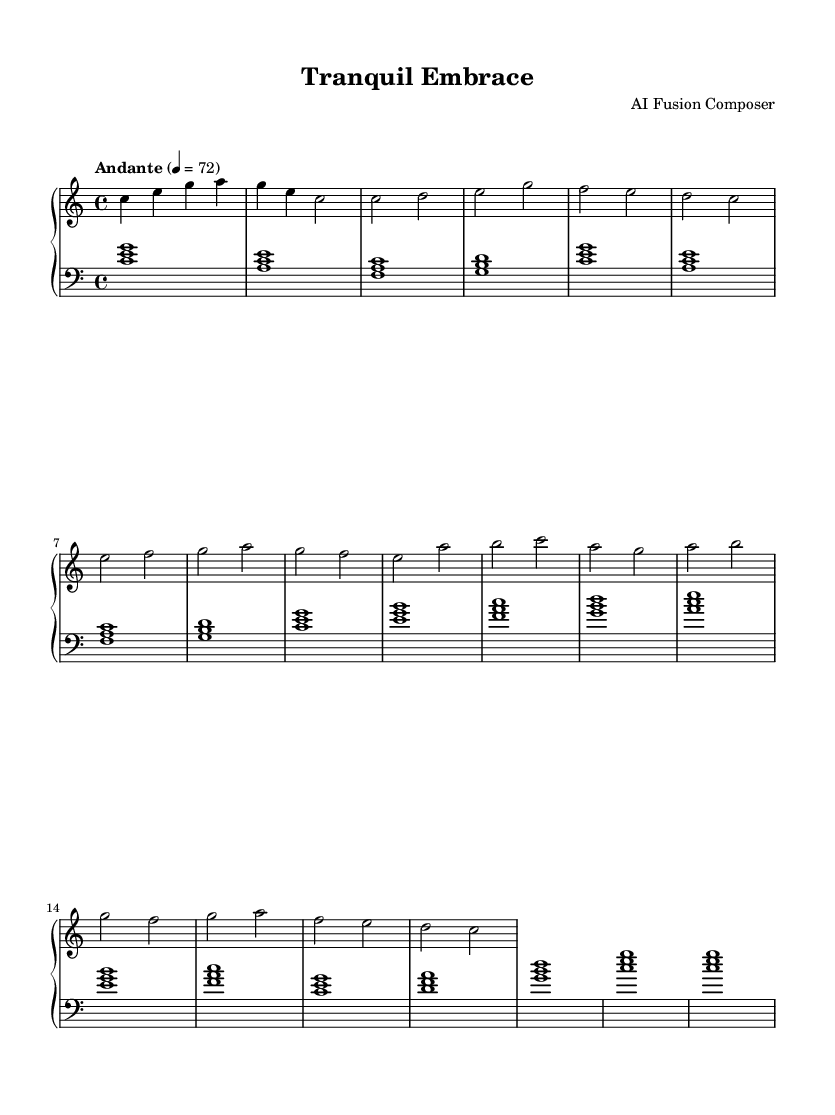What is the key signature of this music? The key signature is C major, which has no sharps or flats, as indicated at the beginning of the music sheet.
Answer: C major What is the time signature of this music? The time signature shown in the music is 4/4, meaning there are four beats in each measure and the quarter note receives one beat.
Answer: 4/4 What is the tempo marking of the piece? The tempo marking indicates "Andante," which means at a moderate walking pace; the marking also includes a metronome indication of 72 beats per minute.
Answer: Andante How many measures are there in the "Chorus" section? The "Chorus" section consists of four measures, as indicated by counting each group of notes in the chorus part of the sheet music.
Answer: 4 What is the first note of the right hand (melody) in the "Verse"? The first note of the "Verse" section in the right hand is C, as determined by looking at the initial note in that section.
Answer: C What is the third chord played in the "Intro" section on the left hand? The third chord in the "Intro" section of the left hand is an F major chord, which includes the notes F, A, and C, recognizable by observing the chord placement on the staff.
Answer: F major What is unique about the blend of instruments in this fusion piece? The piece uniquely blends classical piano sounds with ambient electronica elements, creating a calming and atmospheric arrangement typical of fusion music.
Answer: Classical piano and ambient electronica 